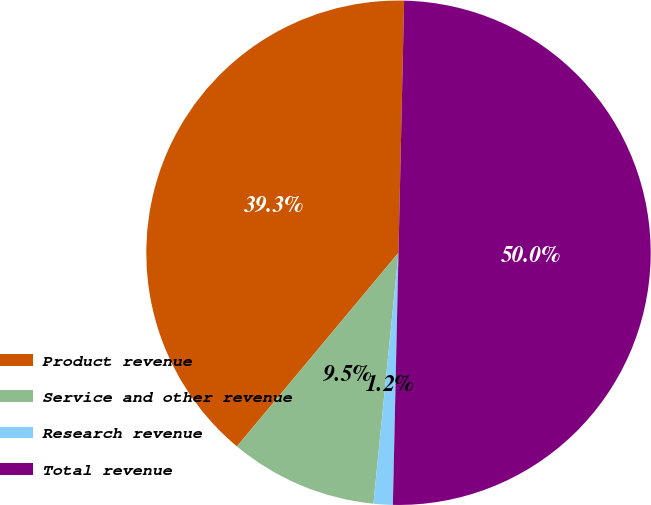Convert chart to OTSL. <chart><loc_0><loc_0><loc_500><loc_500><pie_chart><fcel>Product revenue<fcel>Service and other revenue<fcel>Research revenue<fcel>Total revenue<nl><fcel>39.29%<fcel>9.48%<fcel>1.23%<fcel>50.0%<nl></chart> 